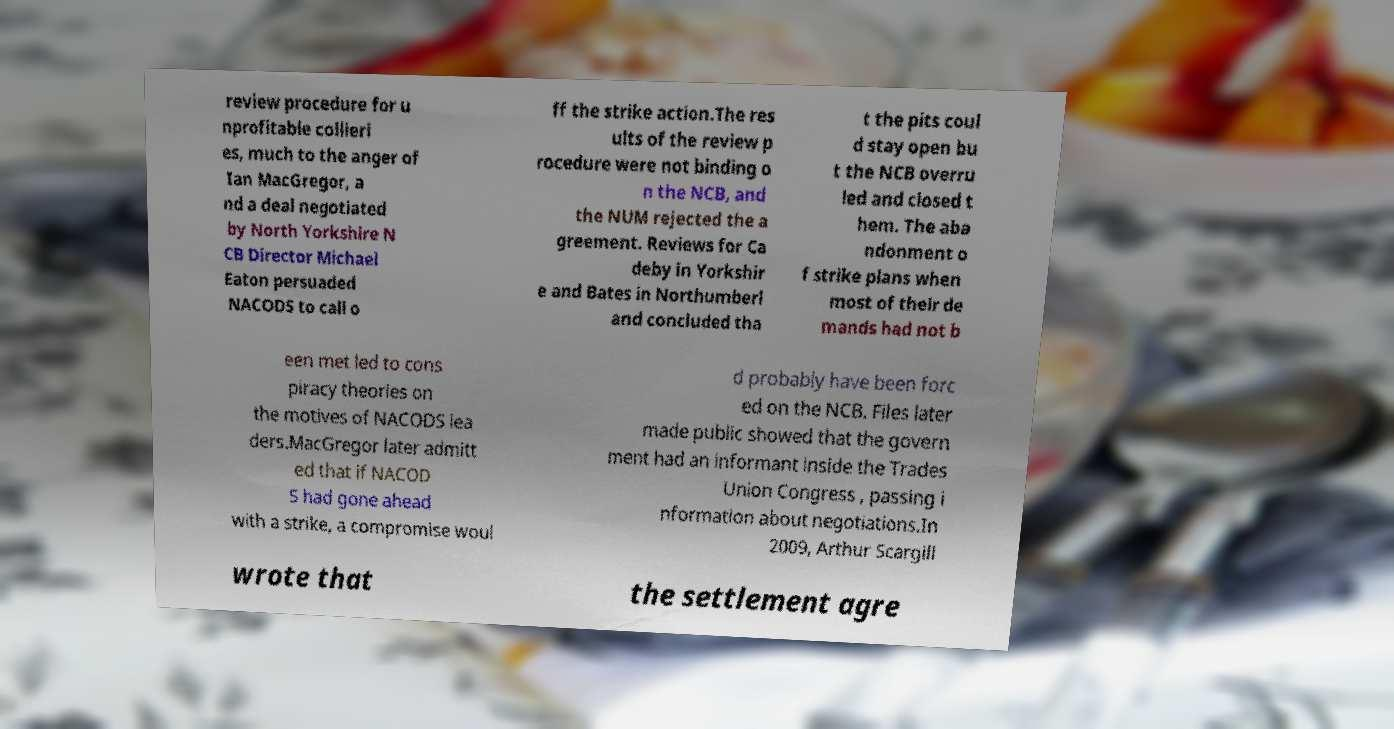Please identify and transcribe the text found in this image. review procedure for u nprofitable collieri es, much to the anger of Ian MacGregor, a nd a deal negotiated by North Yorkshire N CB Director Michael Eaton persuaded NACODS to call o ff the strike action.The res ults of the review p rocedure were not binding o n the NCB, and the NUM rejected the a greement. Reviews for Ca deby in Yorkshir e and Bates in Northumberl and concluded tha t the pits coul d stay open bu t the NCB overru led and closed t hem. The aba ndonment o f strike plans when most of their de mands had not b een met led to cons piracy theories on the motives of NACODS lea ders.MacGregor later admitt ed that if NACOD S had gone ahead with a strike, a compromise woul d probably have been forc ed on the NCB. Files later made public showed that the govern ment had an informant inside the Trades Union Congress , passing i nformation about negotiations.In 2009, Arthur Scargill wrote that the settlement agre 